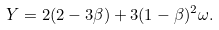<formula> <loc_0><loc_0><loc_500><loc_500>Y = 2 ( 2 - 3 \beta ) + 3 ( 1 - \beta ) ^ { 2 } \omega .</formula> 